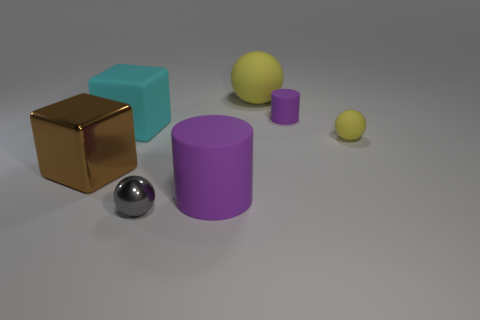Subtract all red blocks. How many yellow spheres are left? 2 Add 2 purple rubber things. How many objects exist? 9 Subtract all yellow rubber balls. How many balls are left? 1 Add 3 large cylinders. How many large cylinders are left? 4 Add 1 cyan blocks. How many cyan blocks exist? 2 Subtract 0 cyan cylinders. How many objects are left? 7 Subtract all blocks. How many objects are left? 5 Subtract 1 balls. How many balls are left? 2 Subtract all green blocks. Subtract all gray balls. How many blocks are left? 2 Subtract all small green matte spheres. Subtract all yellow balls. How many objects are left? 5 